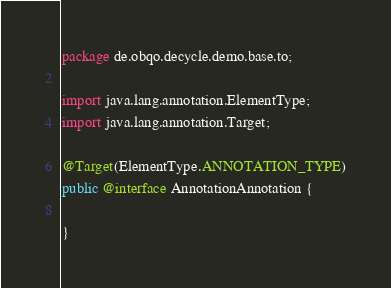<code> <loc_0><loc_0><loc_500><loc_500><_Java_>package de.obqo.decycle.demo.base.to;

import java.lang.annotation.ElementType;
import java.lang.annotation.Target;

@Target(ElementType.ANNOTATION_TYPE)
public @interface AnnotationAnnotation {

}
</code> 